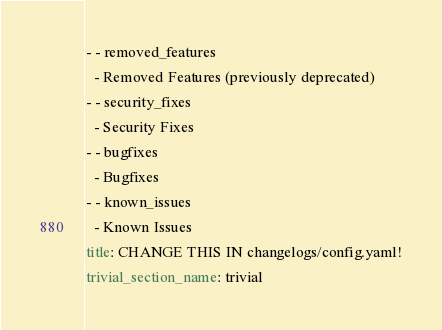<code> <loc_0><loc_0><loc_500><loc_500><_YAML_>- - removed_features
  - Removed Features (previously deprecated)
- - security_fixes
  - Security Fixes
- - bugfixes
  - Bugfixes
- - known_issues
  - Known Issues
title: CHANGE THIS IN changelogs/config.yaml!
trivial_section_name: trivial
</code> 